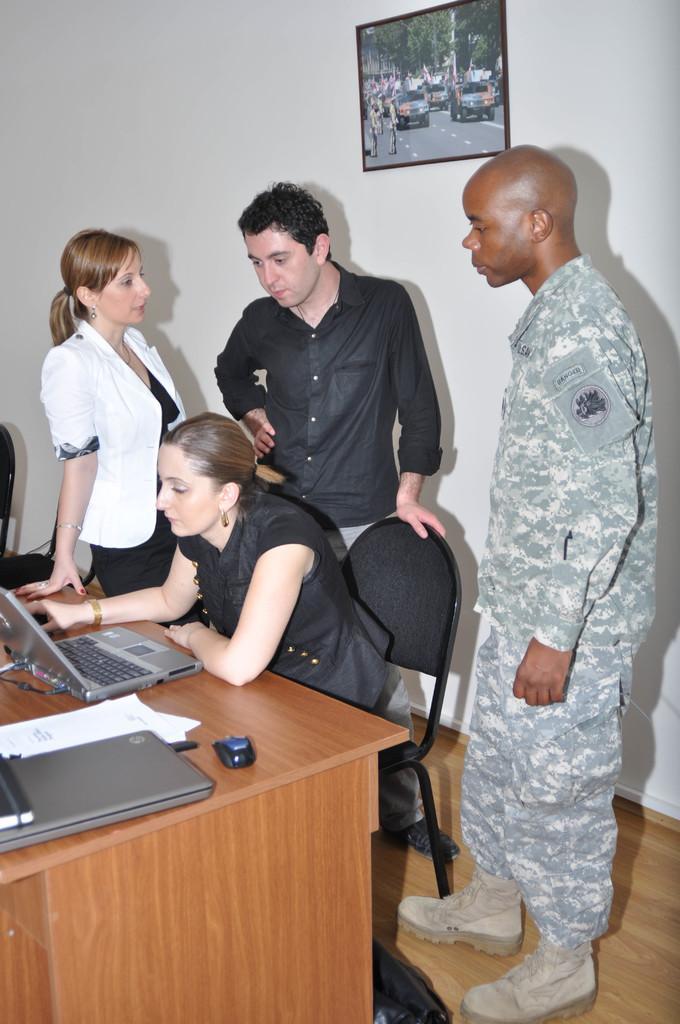Please provide a concise description of this image. A woman is sitting on the chair in front of her there is a table, on which laptop,mouse and papers are there. Behind her there are 3 people standing,a wall and a frame on the wall. 